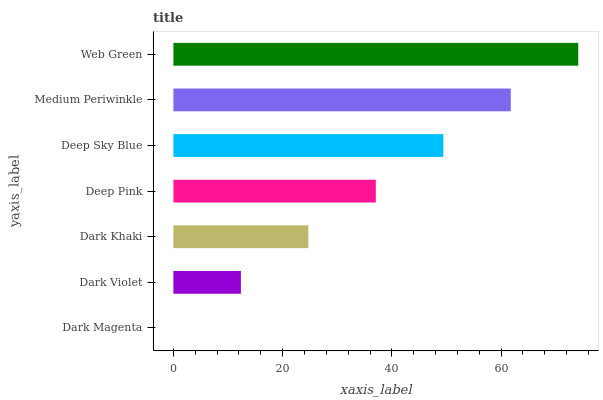Is Dark Magenta the minimum?
Answer yes or no. Yes. Is Web Green the maximum?
Answer yes or no. Yes. Is Dark Violet the minimum?
Answer yes or no. No. Is Dark Violet the maximum?
Answer yes or no. No. Is Dark Violet greater than Dark Magenta?
Answer yes or no. Yes. Is Dark Magenta less than Dark Violet?
Answer yes or no. Yes. Is Dark Magenta greater than Dark Violet?
Answer yes or no. No. Is Dark Violet less than Dark Magenta?
Answer yes or no. No. Is Deep Pink the high median?
Answer yes or no. Yes. Is Deep Pink the low median?
Answer yes or no. Yes. Is Dark Violet the high median?
Answer yes or no. No. Is Deep Sky Blue the low median?
Answer yes or no. No. 